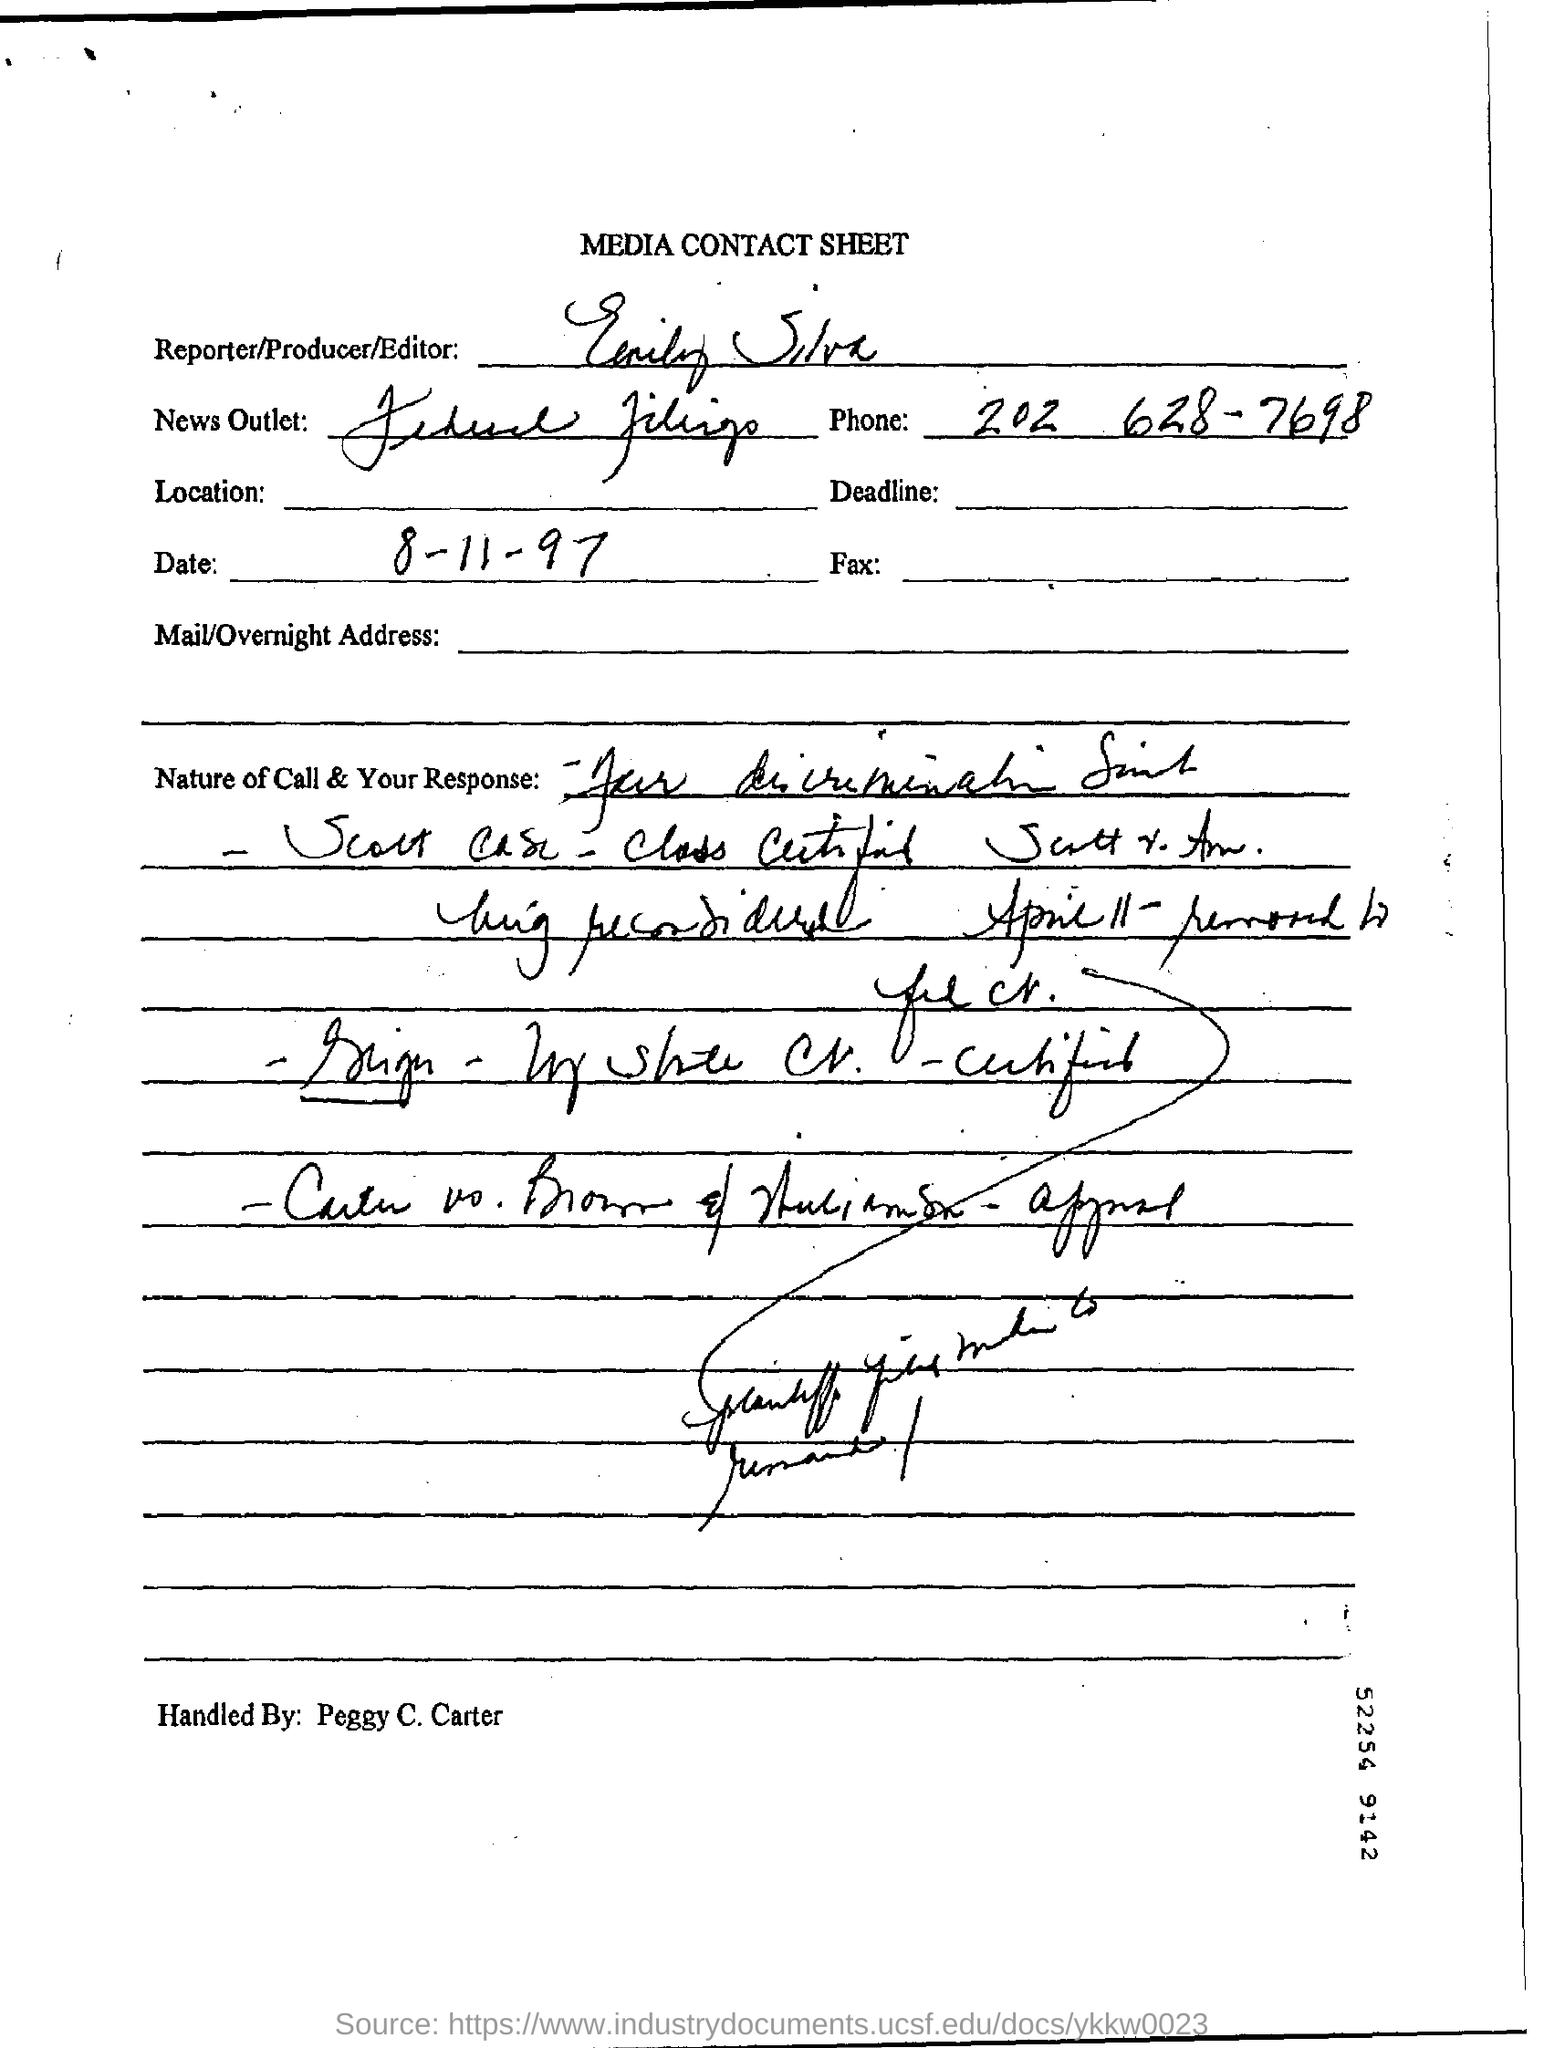What is the Date?
Your response must be concise. 8-11-97. 